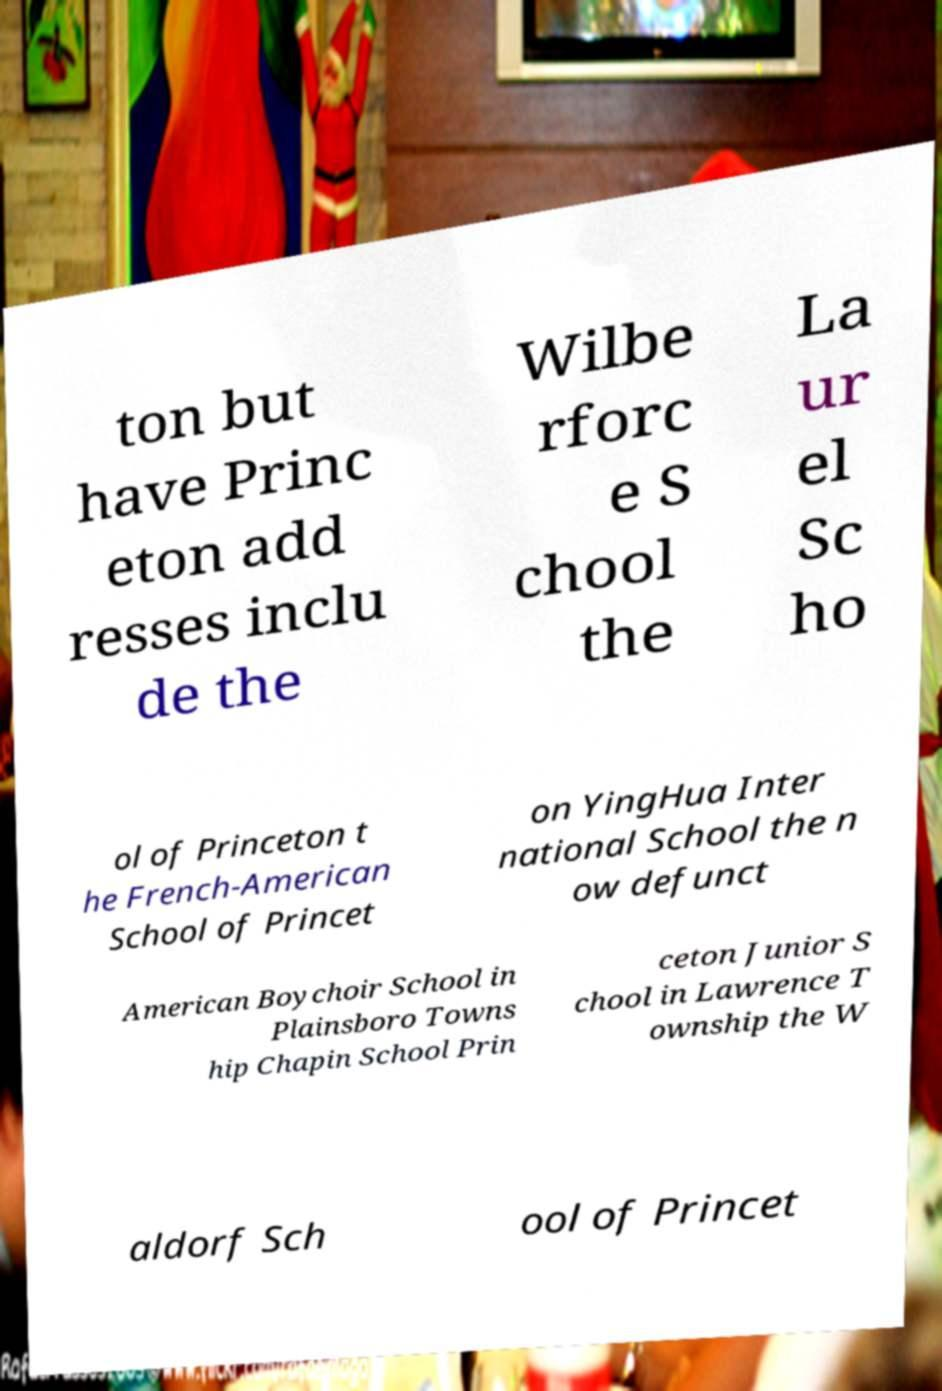Can you accurately transcribe the text from the provided image for me? ton but have Princ eton add resses inclu de the Wilbe rforc e S chool the La ur el Sc ho ol of Princeton t he French-American School of Princet on YingHua Inter national School the n ow defunct American Boychoir School in Plainsboro Towns hip Chapin School Prin ceton Junior S chool in Lawrence T ownship the W aldorf Sch ool of Princet 